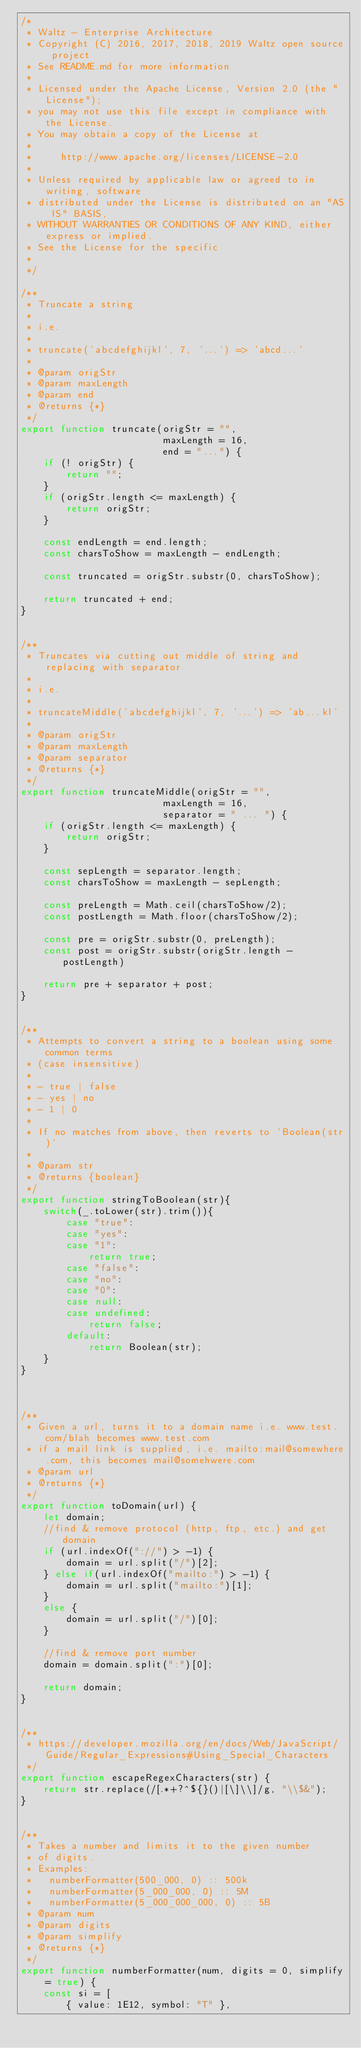<code> <loc_0><loc_0><loc_500><loc_500><_JavaScript_>/*
 * Waltz - Enterprise Architecture
 * Copyright (C) 2016, 2017, 2018, 2019 Waltz open source project
 * See README.md for more information
 *
 * Licensed under the Apache License, Version 2.0 (the "License");
 * you may not use this file except in compliance with the License.
 * You may obtain a copy of the License at
 *
 *     http://www.apache.org/licenses/LICENSE-2.0
 *
 * Unless required by applicable law or agreed to in writing, software
 * distributed under the License is distributed on an "AS IS" BASIS,
 * WITHOUT WARRANTIES OR CONDITIONS OF ANY KIND, either express or implied.
 * See the License for the specific
 *
 */

/**
 * Truncate a string
 *
 * i.e.
 *
 * truncate('abcdefghijkl', 7, '...') => 'abcd...'
 *
 * @param origStr
 * @param maxLength
 * @param end
 * @returns {*}
 */
export function truncate(origStr = "",
                         maxLength = 16,
                         end = "...") {
    if (! origStr) {
        return "";
    }
    if (origStr.length <= maxLength) {
        return origStr;
    }

    const endLength = end.length;
    const charsToShow = maxLength - endLength;

    const truncated = origStr.substr(0, charsToShow);

    return truncated + end;
}


/**
 * Truncates via cutting out middle of string and replacing with separator
 *
 * i.e.
 *
 * truncateMiddle('abcdefghijkl', 7, '...') => 'ab...kl'
 *
 * @param origStr
 * @param maxLength
 * @param separator
 * @returns {*}
 */
export function truncateMiddle(origStr = "",
                         maxLength = 16,
                         separator = " ... ") {
    if (origStr.length <= maxLength) {
        return origStr;
    }

    const sepLength = separator.length;
    const charsToShow = maxLength - sepLength;

    const preLength = Math.ceil(charsToShow/2);
    const postLength = Math.floor(charsToShow/2);

    const pre = origStr.substr(0, preLength);
    const post = origStr.substr(origStr.length - postLength)

    return pre + separator + post;
}


/**
 * Attempts to convert a string to a boolean using some common terms
 * (case insensitive)
 *
 * - true | false
 * - yes | no
 * - 1 | 0
 *
 * If no matches from above, then reverts to `Boolean(str)`
 *
 * @param str
 * @returns {boolean}
 */
export function stringToBoolean(str){
    switch(_.toLower(str).trim()){
        case "true":
        case "yes":
        case "1":
            return true;
        case "false":
        case "no":
        case "0":
        case null:
        case undefined:
            return false;
        default:
            return Boolean(str);
    }
}



/**
 * Given a url, turns it to a domain name i.e. www.test.com/blah becomes www.test.com
 * if a mail link is supplied, i.e. mailto:mail@somewhere.com, this becomes mail@somehwere.com
 * @param url
 * @returns {*}
 */
export function toDomain(url) {
    let domain;
    //find & remove protocol (http, ftp, etc.) and get domain
    if (url.indexOf("://") > -1) {
        domain = url.split("/")[2];
    } else if(url.indexOf("mailto:") > -1) {
        domain = url.split("mailto:")[1];
    }
    else {
        domain = url.split("/")[0];
    }

    //find & remove port number
    domain = domain.split(":")[0];

    return domain;
}


/**
 * https://developer.mozilla.org/en/docs/Web/JavaScript/Guide/Regular_Expressions#Using_Special_Characters
 */
export function escapeRegexCharacters(str) {
    return str.replace(/[.*+?^${}()|[\]\\]/g, "\\$&");
}


/**
 * Takes a number and limits it to the given number
 * of digits.
 * Examples:
 *   numberFormatter(500_000, 0) :: 500k
 *   numberFormatter(5_000_000, 0) :: 5M
 *   numberFormatter(5_000_000_000, 0) :: 5B
 * @param num
 * @param digits
 * @param simplify
 * @returns {*}
 */
export function numberFormatter(num, digits = 0, simplify = true) {
    const si = [
        { value: 1E12, symbol: "T" },</code> 